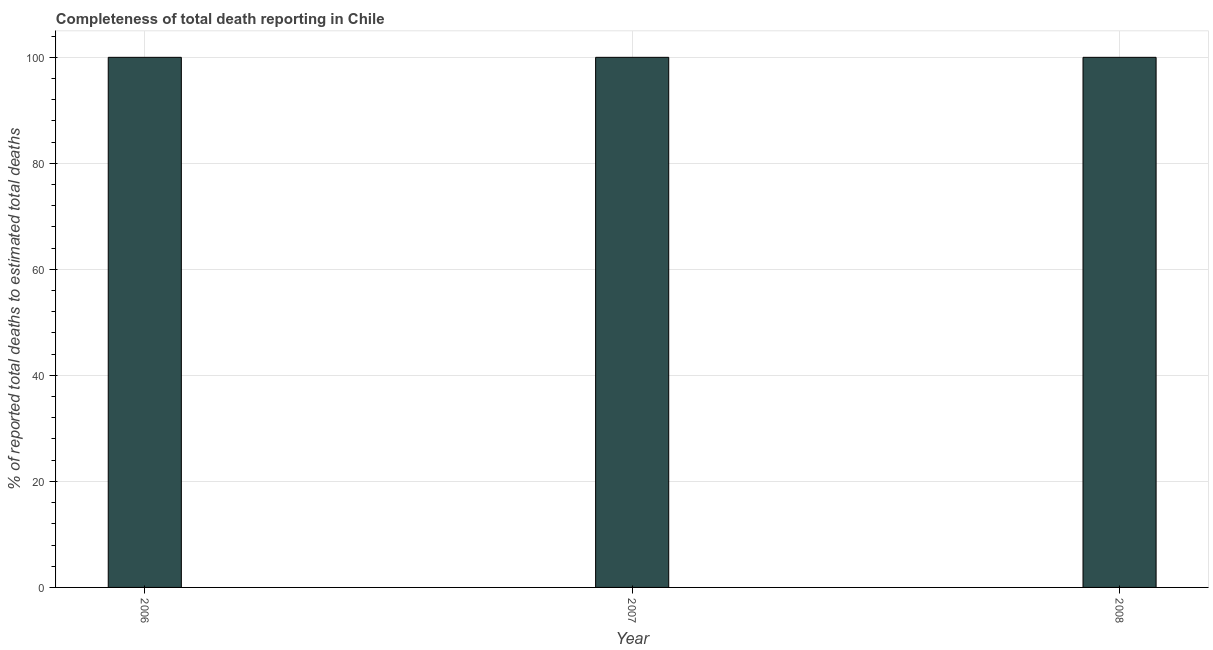Does the graph contain any zero values?
Your response must be concise. No. What is the title of the graph?
Your response must be concise. Completeness of total death reporting in Chile. What is the label or title of the X-axis?
Provide a short and direct response. Year. What is the label or title of the Y-axis?
Provide a short and direct response. % of reported total deaths to estimated total deaths. Across all years, what is the minimum completeness of total death reports?
Give a very brief answer. 100. What is the sum of the completeness of total death reports?
Your answer should be very brief. 300. What is the average completeness of total death reports per year?
Provide a short and direct response. 100. What is the median completeness of total death reports?
Ensure brevity in your answer.  100. What is the ratio of the completeness of total death reports in 2006 to that in 2008?
Offer a very short reply. 1. What is the difference between the highest and the second highest completeness of total death reports?
Ensure brevity in your answer.  0. Is the sum of the completeness of total death reports in 2006 and 2008 greater than the maximum completeness of total death reports across all years?
Provide a short and direct response. Yes. In how many years, is the completeness of total death reports greater than the average completeness of total death reports taken over all years?
Keep it short and to the point. 0. How many years are there in the graph?
Ensure brevity in your answer.  3. Are the values on the major ticks of Y-axis written in scientific E-notation?
Offer a very short reply. No. What is the % of reported total deaths to estimated total deaths in 2007?
Make the answer very short. 100. What is the difference between the % of reported total deaths to estimated total deaths in 2007 and 2008?
Make the answer very short. 0. What is the ratio of the % of reported total deaths to estimated total deaths in 2006 to that in 2007?
Your answer should be very brief. 1. 